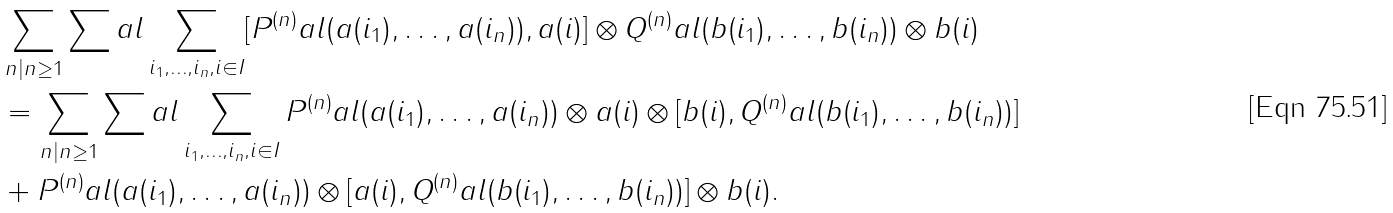<formula> <loc_0><loc_0><loc_500><loc_500>& \sum _ { n | n \geq 1 } \sum _ { \ } a l \sum _ { i _ { 1 } , \dots , i _ { n } , i \in I } [ P ^ { ( n ) } _ { \ } a l ( a ( i _ { 1 } ) , \dots , a ( i _ { n } ) ) , a ( i ) ] \otimes Q ^ { ( n ) } _ { \ } a l ( b ( i _ { 1 } ) , \dots , b ( i _ { n } ) ) \otimes b ( i ) \\ & = \sum _ { n | n \geq 1 } \sum _ { \ } a l \sum _ { i _ { 1 } , \dots , i _ { n } , i \in I } P ^ { ( n ) } _ { \ } a l ( a ( i _ { 1 } ) , \dots , a ( i _ { n } ) ) \otimes a ( i ) \otimes [ b ( i ) , Q ^ { ( n ) } _ { \ } a l ( b ( i _ { 1 } ) , \dots , b ( i _ { n } ) ) ] \\ & + P ^ { ( n ) } _ { \ } a l ( a ( i _ { 1 } ) , \dots , a ( i _ { n } ) ) \otimes [ a ( i ) , Q ^ { ( n ) } _ { \ } a l ( b ( i _ { 1 } ) , \dots , b ( i _ { n } ) ) ] \otimes b ( i ) .</formula> 